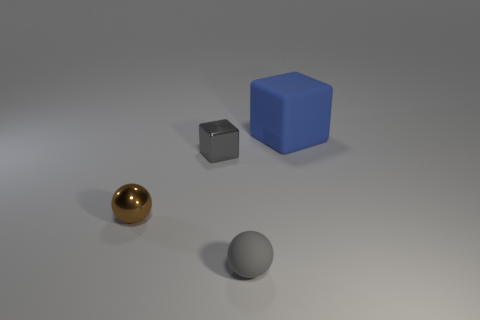Add 4 big brown rubber cylinders. How many objects exist? 8 Subtract all tiny rubber balls. Subtract all large blue matte blocks. How many objects are left? 2 Add 4 blue matte objects. How many blue matte objects are left? 5 Add 3 green blocks. How many green blocks exist? 3 Subtract 0 yellow spheres. How many objects are left? 4 